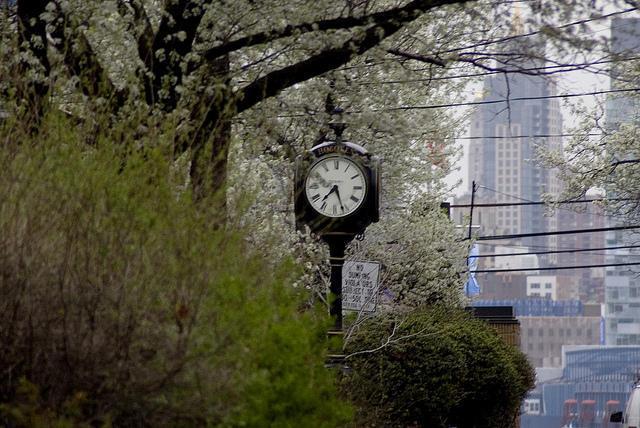How many cars have a surfboard on them?
Give a very brief answer. 0. 